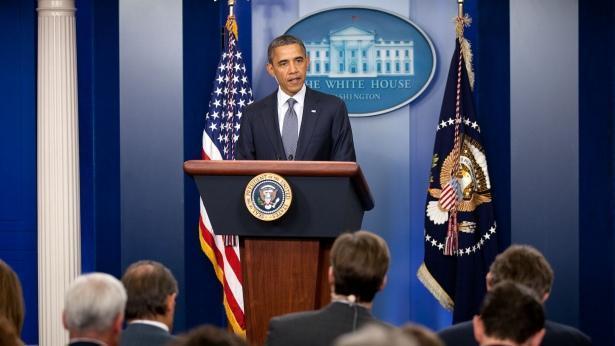How many people are there?
Give a very brief answer. 6. How many of the train cars can you see someone sticking their head out of?
Give a very brief answer. 0. 